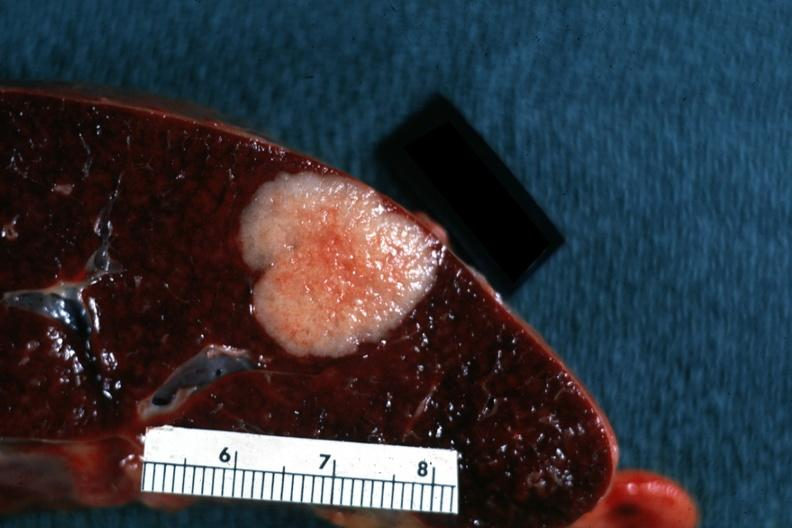s spleen present?
Answer the question using a single word or phrase. Yes 